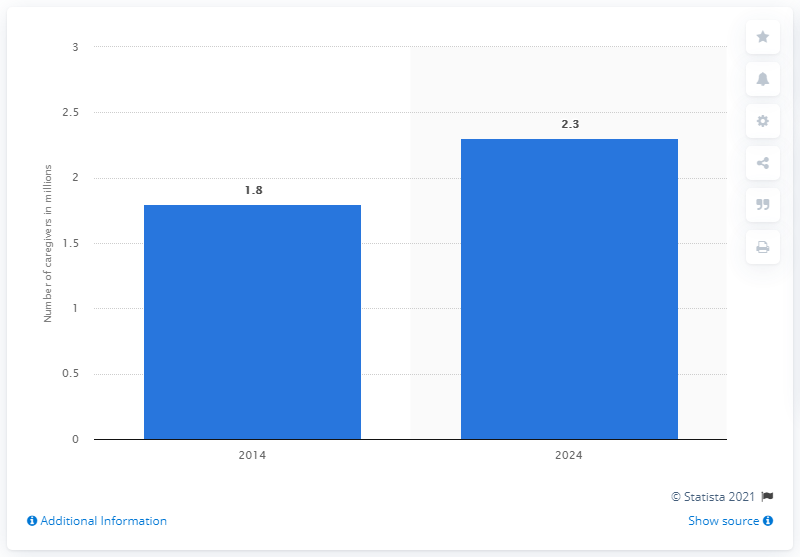Draw attention to some important aspects in this diagram. In 2014, there were approximately 1.8 caregivers in the United States. By 2024, it is projected that there will be 2.3 million caregivers in the United States. The forecast for caregivers in the home care industry in the United States is for the demand to increase in 2024. 